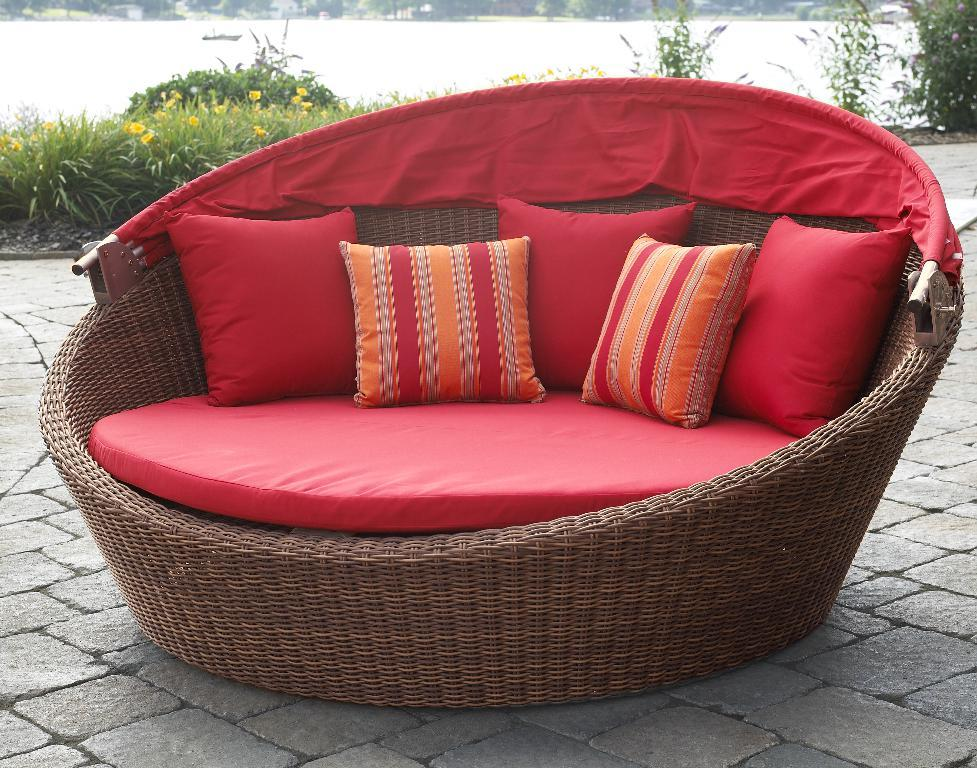What type of furniture is in the image? There is a wooden couch in the image. What is on the couch? There are cushions on the couch. What can be seen in the background of the image? There are plants and yellow-colored flowers in the background of the image. Is there any water visible in the background of the image? Yes, there is water visible in the background of the image. What type of operation is being performed on the yam in the image? There is no yam or operation present in the image. 